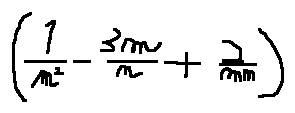Convert formula to latex. <formula><loc_0><loc_0><loc_500><loc_500>( \frac { 1 } { m ^ { 2 } } - \frac { 3 m } { n } + \frac { 2 } { m n } )</formula> 